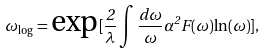<formula> <loc_0><loc_0><loc_500><loc_500>\omega _ { \log } = \text {exp} [ \frac { 2 } { \lambda } \int { \frac { d \omega } { \omega } \alpha ^ { 2 } F ( \omega ) { \ln } ( \omega ) } ] ,</formula> 